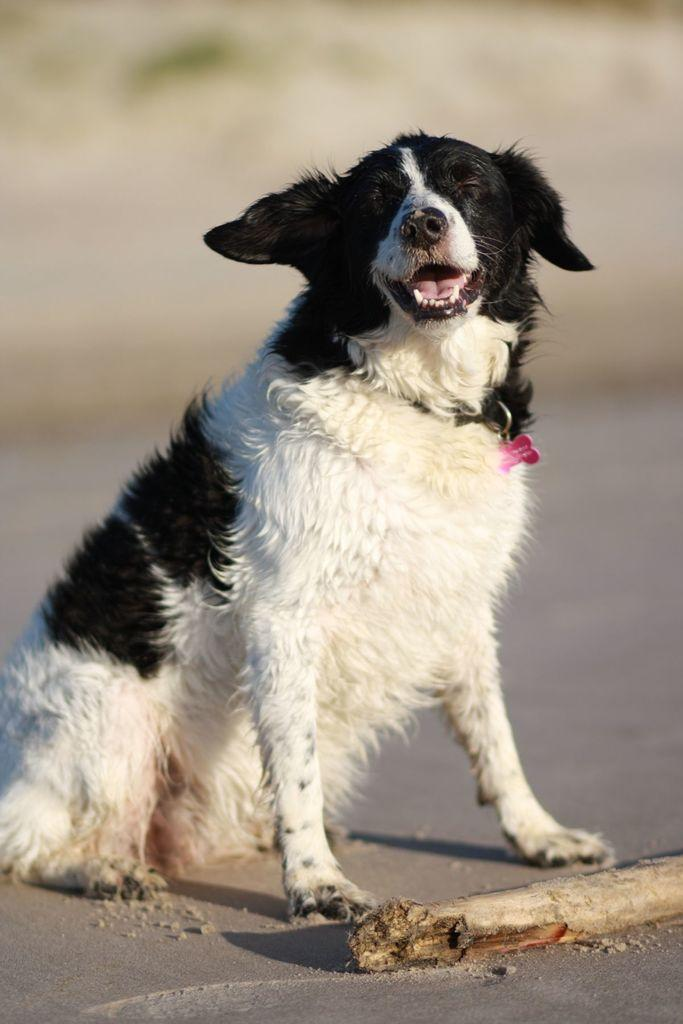What is the overall appearance of the background in the image? The background of the image is blurred. What type of animal can be seen in the image? There is a dog in the image. What small accessory is visible in the image? A key-chain is visible in the image. What object is blocking the road in the image? There is a wooden log on the road in the image. What type of skirt is the dog wearing in the image? There is no skirt present in the image, as the dog is not wearing any clothing. 